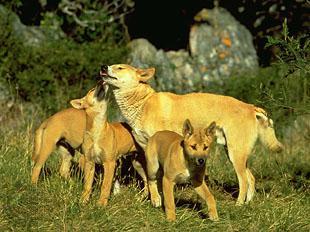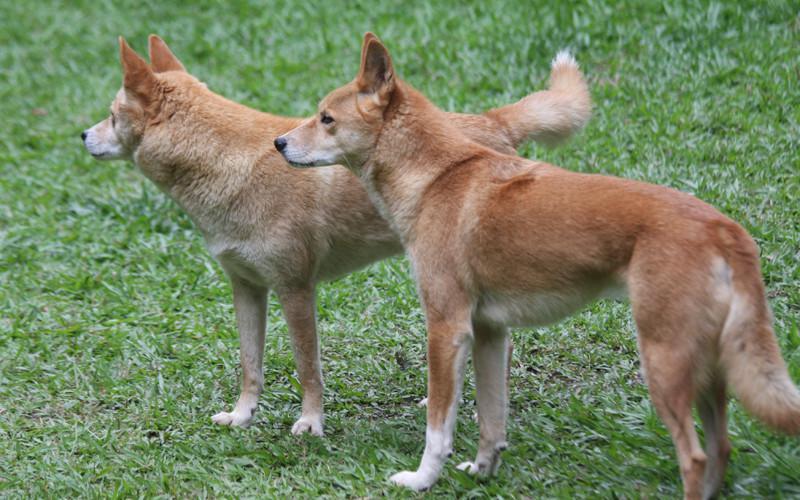The first image is the image on the left, the second image is the image on the right. For the images shown, is this caption "One of the images shows exactly one animal in the grass alone." true? Answer yes or no. No. The first image is the image on the left, the second image is the image on the right. Considering the images on both sides, is "The canine on the left is laying down, the canine on the right is standing up." valid? Answer yes or no. No. 